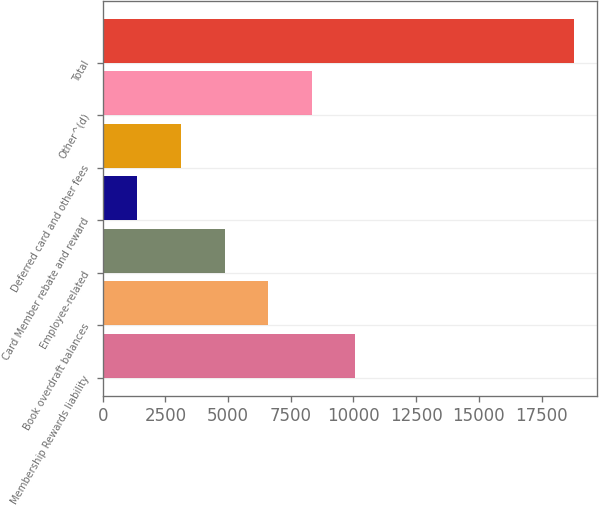Convert chart to OTSL. <chart><loc_0><loc_0><loc_500><loc_500><bar_chart><fcel>Membership Rewards liability<fcel>Book overdraft balances<fcel>Employee-related<fcel>Card Member rebate and reward<fcel>Deferred card and other fees<fcel>Other^(d)<fcel>Total<nl><fcel>10079.5<fcel>6600.5<fcel>4861<fcel>1382<fcel>3121.5<fcel>8340<fcel>18777<nl></chart> 